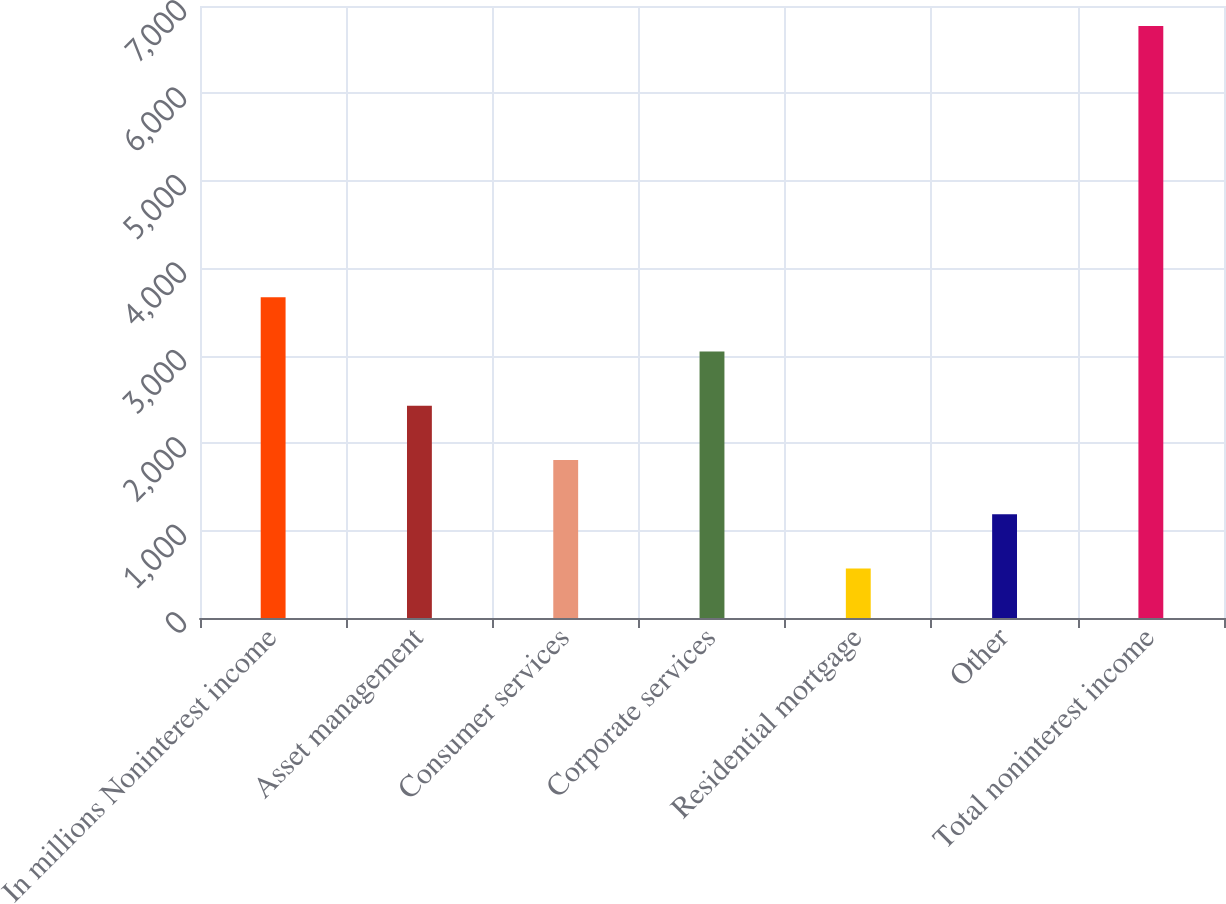<chart> <loc_0><loc_0><loc_500><loc_500><bar_chart><fcel>In millions Noninterest income<fcel>Asset management<fcel>Consumer services<fcel>Corporate services<fcel>Residential mortgage<fcel>Other<fcel>Total noninterest income<nl><fcel>3669<fcel>2428.2<fcel>1807.8<fcel>3048.6<fcel>567<fcel>1187.4<fcel>6771<nl></chart> 